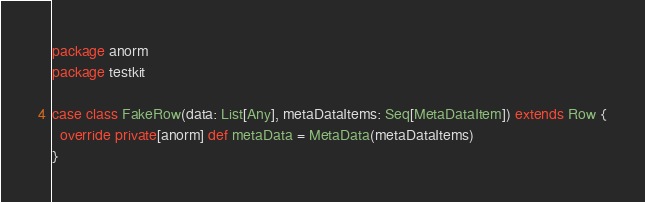Convert code to text. <code><loc_0><loc_0><loc_500><loc_500><_Scala_>package anorm
package testkit

case class FakeRow(data: List[Any], metaDataItems: Seq[MetaDataItem]) extends Row {
  override private[anorm] def metaData = MetaData(metaDataItems)
}
</code> 